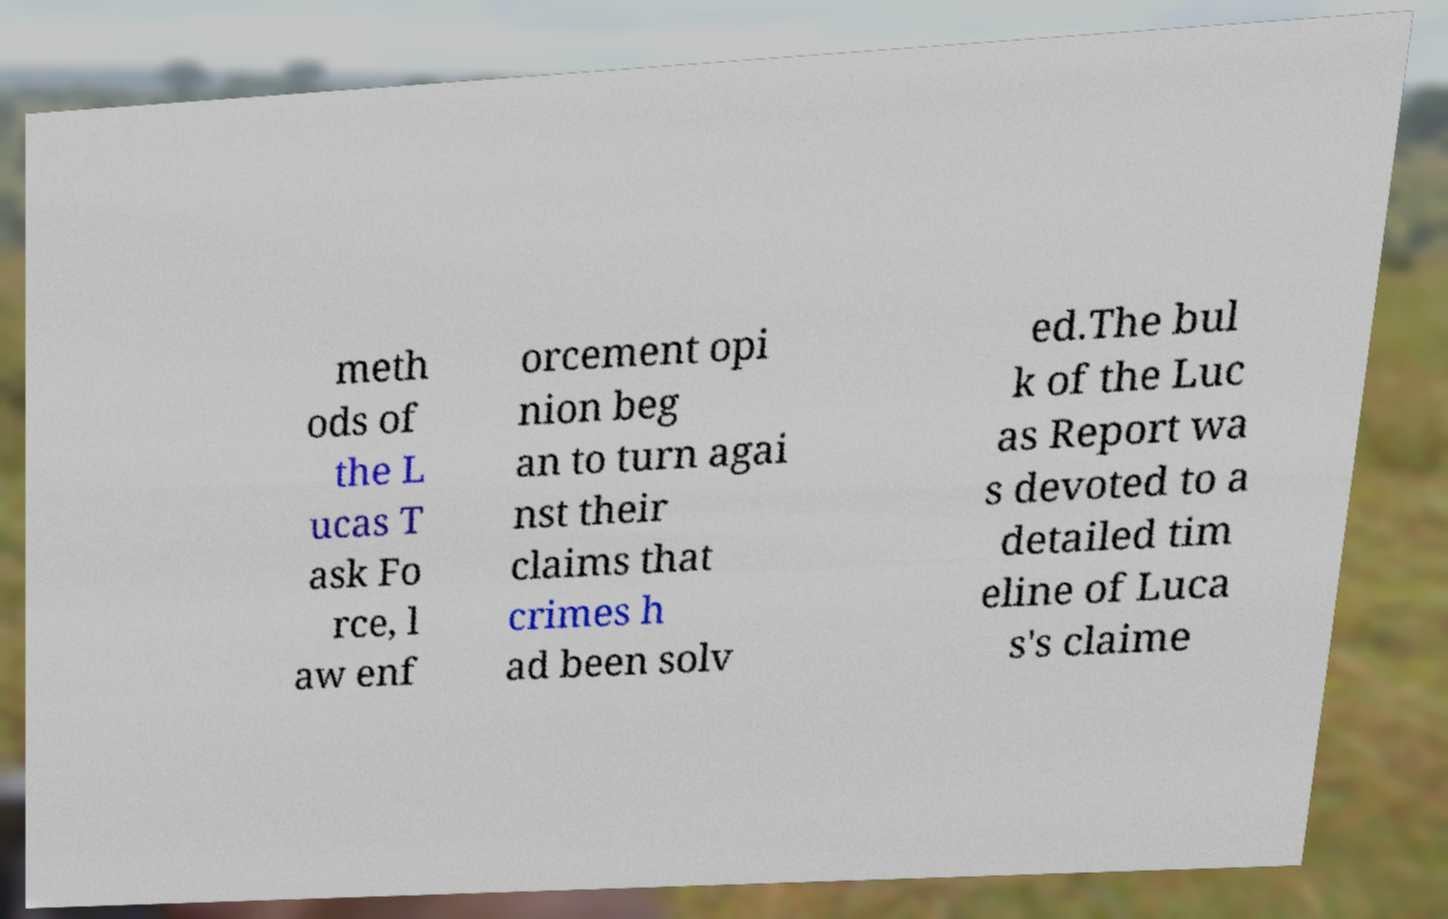Could you assist in decoding the text presented in this image and type it out clearly? meth ods of the L ucas T ask Fo rce, l aw enf orcement opi nion beg an to turn agai nst their claims that crimes h ad been solv ed.The bul k of the Luc as Report wa s devoted to a detailed tim eline of Luca s's claime 